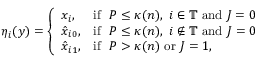<formula> <loc_0><loc_0><loc_500><loc_500>\eta _ { i } ( y ) = \left \{ \begin{array} { l l } { x _ { i } , } & { i f \ \ P \leq \kappa ( n ) , \ i \in \mathbb { T } a n d J = 0 } \\ { \hat { x } _ { i 0 } , } & { i f \ \ P \leq \kappa ( n ) , \ i \notin \mathbb { T } a n d J = 0 } \\ { \hat { x } _ { i 1 } , } & { i f \ \ P > \kappa ( n ) o r J = 1 , } \end{array}</formula> 